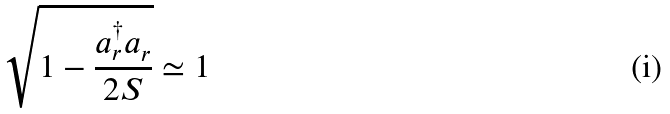<formula> <loc_0><loc_0><loc_500><loc_500>\sqrt { 1 - \frac { a _ { r } ^ { \dag } a _ { r } } { 2 S } } \simeq 1</formula> 